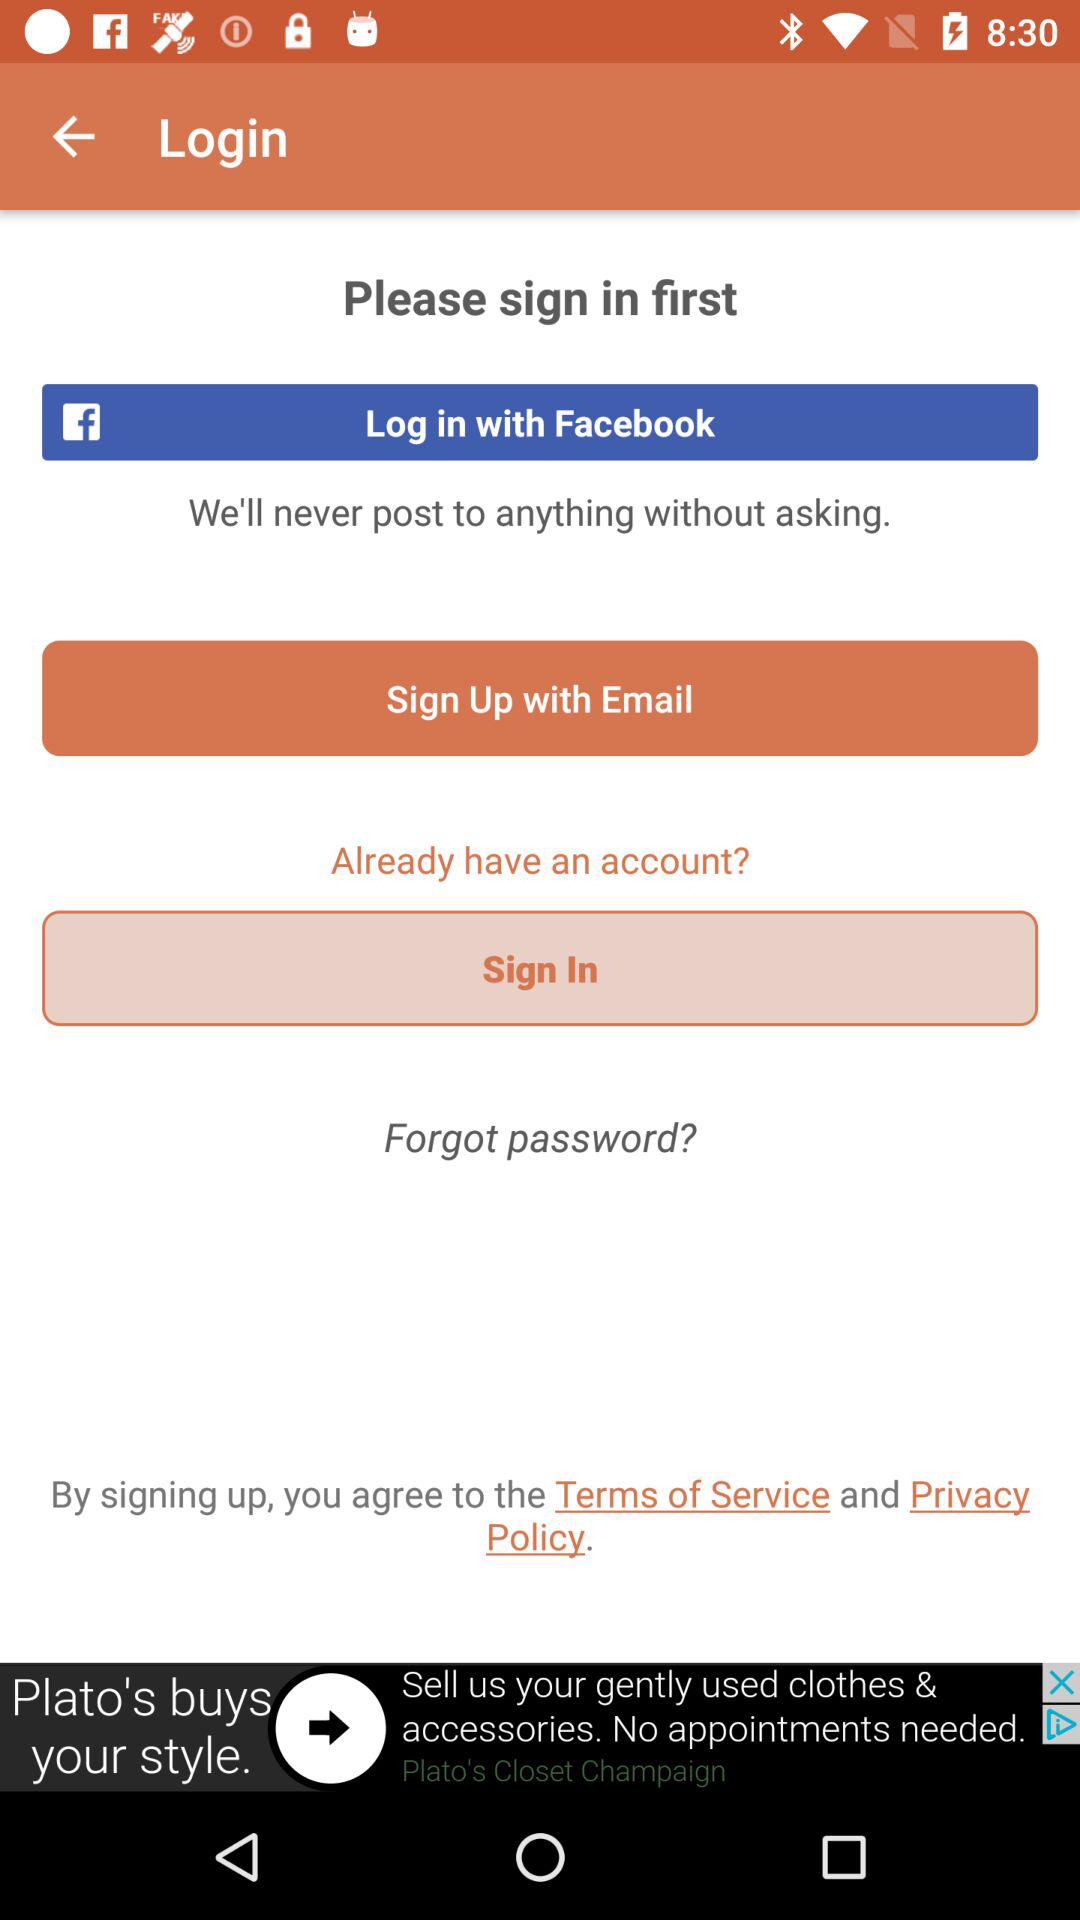Which option is given for sign up? The given option for sign up is "Email". 